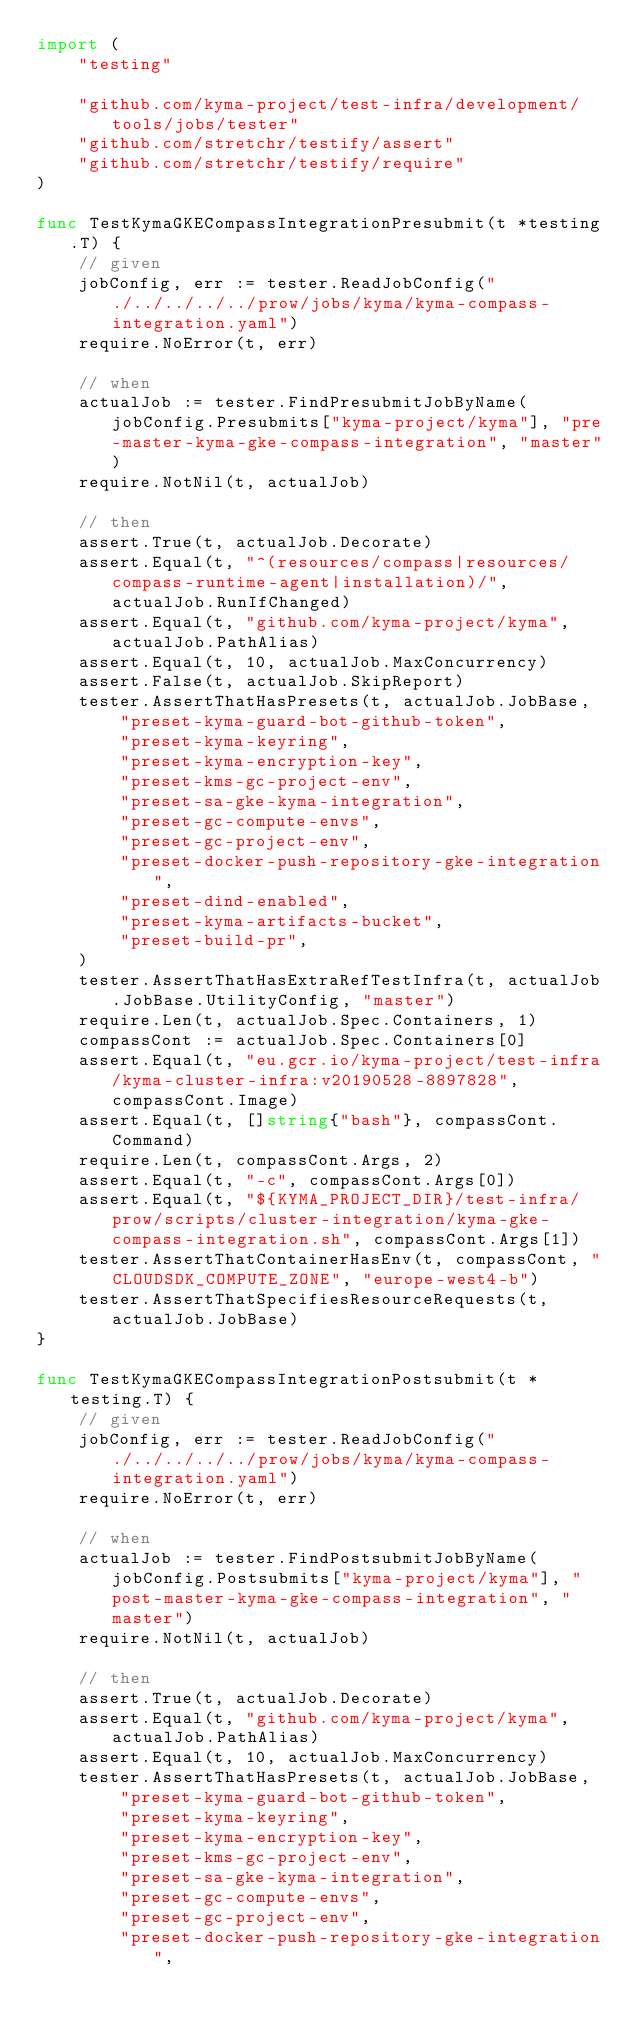Convert code to text. <code><loc_0><loc_0><loc_500><loc_500><_Go_>import (
	"testing"

	"github.com/kyma-project/test-infra/development/tools/jobs/tester"
	"github.com/stretchr/testify/assert"
	"github.com/stretchr/testify/require"
)

func TestKymaGKECompassIntegrationPresubmit(t *testing.T) {
	// given
	jobConfig, err := tester.ReadJobConfig("./../../../../prow/jobs/kyma/kyma-compass-integration.yaml")
	require.NoError(t, err)

	// when
	actualJob := tester.FindPresubmitJobByName(jobConfig.Presubmits["kyma-project/kyma"], "pre-master-kyma-gke-compass-integration", "master")
	require.NotNil(t, actualJob)

	// then
	assert.True(t, actualJob.Decorate)
	assert.Equal(t, "^(resources/compass|resources/compass-runtime-agent|installation)/", actualJob.RunIfChanged)
	assert.Equal(t, "github.com/kyma-project/kyma", actualJob.PathAlias)
	assert.Equal(t, 10, actualJob.MaxConcurrency)
	assert.False(t, actualJob.SkipReport)
	tester.AssertThatHasPresets(t, actualJob.JobBase,
		"preset-kyma-guard-bot-github-token",
		"preset-kyma-keyring",
		"preset-kyma-encryption-key",
		"preset-kms-gc-project-env",
		"preset-sa-gke-kyma-integration",
		"preset-gc-compute-envs",
		"preset-gc-project-env",
		"preset-docker-push-repository-gke-integration",
		"preset-dind-enabled",
		"preset-kyma-artifacts-bucket",
		"preset-build-pr",
	)
	tester.AssertThatHasExtraRefTestInfra(t, actualJob.JobBase.UtilityConfig, "master")
	require.Len(t, actualJob.Spec.Containers, 1)
	compassCont := actualJob.Spec.Containers[0]
	assert.Equal(t, "eu.gcr.io/kyma-project/test-infra/kyma-cluster-infra:v20190528-8897828", compassCont.Image)
	assert.Equal(t, []string{"bash"}, compassCont.Command)
	require.Len(t, compassCont.Args, 2)
	assert.Equal(t, "-c", compassCont.Args[0])
	assert.Equal(t, "${KYMA_PROJECT_DIR}/test-infra/prow/scripts/cluster-integration/kyma-gke-compass-integration.sh", compassCont.Args[1])
	tester.AssertThatContainerHasEnv(t, compassCont, "CLOUDSDK_COMPUTE_ZONE", "europe-west4-b")
	tester.AssertThatSpecifiesResourceRequests(t, actualJob.JobBase)
}

func TestKymaGKECompassIntegrationPostsubmit(t *testing.T) {
	// given
	jobConfig, err := tester.ReadJobConfig("./../../../../prow/jobs/kyma/kyma-compass-integration.yaml")
	require.NoError(t, err)

	// when
	actualJob := tester.FindPostsubmitJobByName(jobConfig.Postsubmits["kyma-project/kyma"], "post-master-kyma-gke-compass-integration", "master")
	require.NotNil(t, actualJob)

	// then
	assert.True(t, actualJob.Decorate)
	assert.Equal(t, "github.com/kyma-project/kyma", actualJob.PathAlias)
	assert.Equal(t, 10, actualJob.MaxConcurrency)
	tester.AssertThatHasPresets(t, actualJob.JobBase,
		"preset-kyma-guard-bot-github-token",
		"preset-kyma-keyring",
		"preset-kyma-encryption-key",
		"preset-kms-gc-project-env",
		"preset-sa-gke-kyma-integration",
		"preset-gc-compute-envs",
		"preset-gc-project-env",
		"preset-docker-push-repository-gke-integration",</code> 